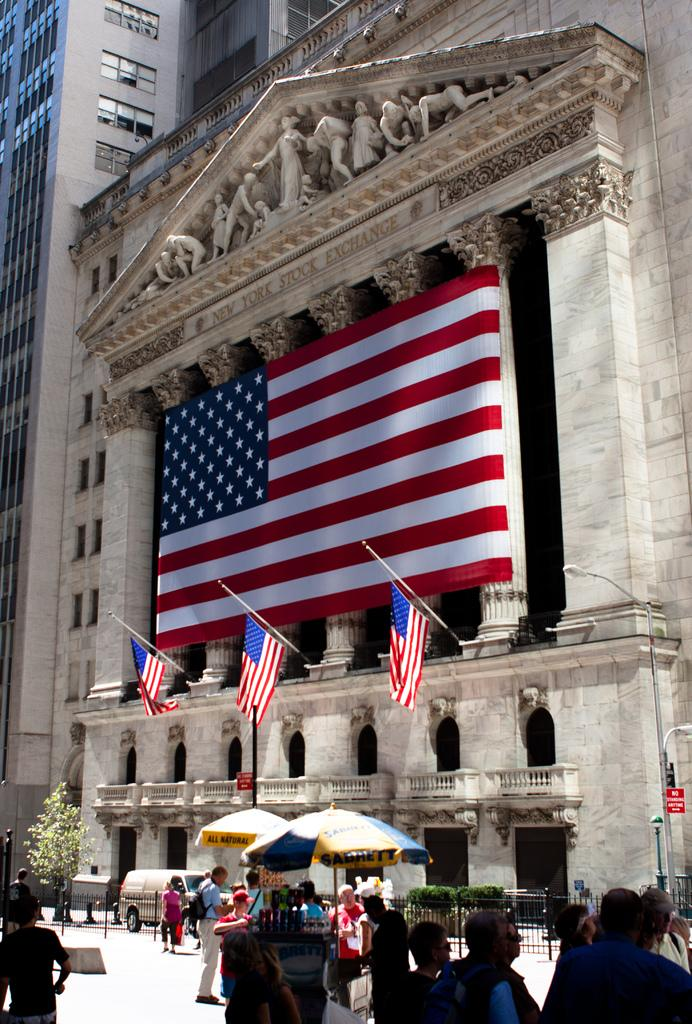Who or what is present in the image? There are people in the image. What structures can be seen in the image? There are two stalls in the image. What is visible in the background of the image? There is a building in the background of the image. What decorations are on the building? The building has flags on it. Can you tell me how many horses are tied to the stalls in the image? There are no horses present in the image; only people and stalls can be seen. Where is the kitten playing in the image? There is no kitten present in the image. 